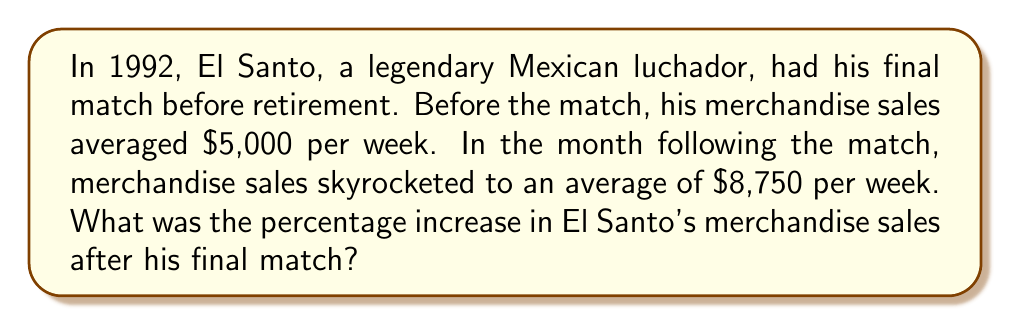Solve this math problem. To calculate the percentage increase, we'll use the following formula:

$$ \text{Percentage Increase} = \frac{\text{Increase}}{\text{Original Amount}} \times 100\% $$

Let's break this down step-by-step:

1. Calculate the increase in sales:
   $$ \text{Increase} = \text{New Amount} - \text{Original Amount} $$
   $$ \text{Increase} = \$8,750 - \$5,000 = \$3,750 $$

2. Divide the increase by the original amount:
   $$ \frac{\text{Increase}}{\text{Original Amount}} = \frac{\$3,750}{\$5,000} = 0.75 $$

3. Convert to a percentage by multiplying by 100%:
   $$ 0.75 \times 100\% = 75\% $$

Therefore, the percentage increase in El Santo's merchandise sales after his final match was 75%.
Answer: 75% 